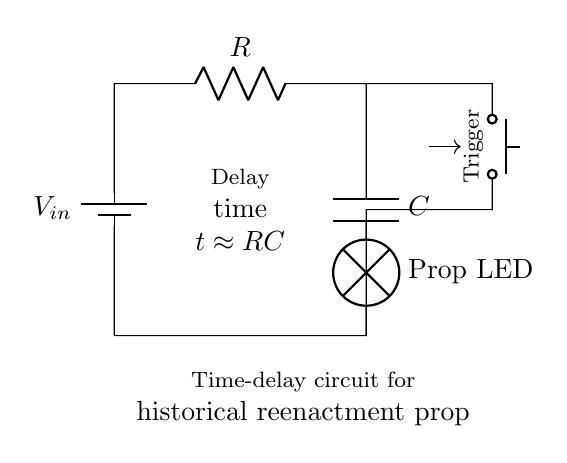What is the main purpose of this circuit? The circuit is designed for time delay, specifically to activate a prop LED with a delay when triggered. This is indicated by the label on the circuit and the components used.
Answer: Time-delay What components are connected to the battery? The battery is connected to the resistor and the capacitor in series. The circuit diagram shows a direct connection from the battery to these components, which are essential for creating the time delay.
Answer: Resistor and Capacitor What is the relationship between resistance and time delay? The time delay in a resistor-capacitor circuit can be calculated using the formula t ≈ RC, where R is resistance and C is capacitance. This relationship indicates that a higher resistance or capacitance leads to a longer time delay.
Answer: Directly proportional What does the push button do in this circuit? The push button acts as a trigger to initiate the circuit's time delay mechanism. When pressed, it completes the circuit and allows current to flow, engaging the components that lead to activating the prop LED after the delay.
Answer: Trigger activation How can the time delay be adjusted in this circuit? The time delay can be adjusted by changing the values of either the resistor or the capacitor. Since t ≈ RC, increasing either component will increase the time it takes before the prop LED is lit.
Answer: Change R or C 